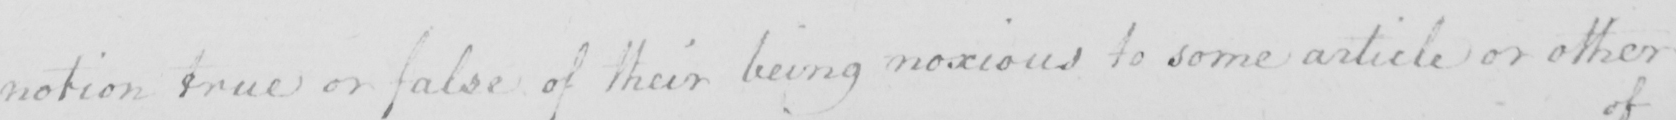Please provide the text content of this handwritten line. notion true or false of their being noxious to some article or other 